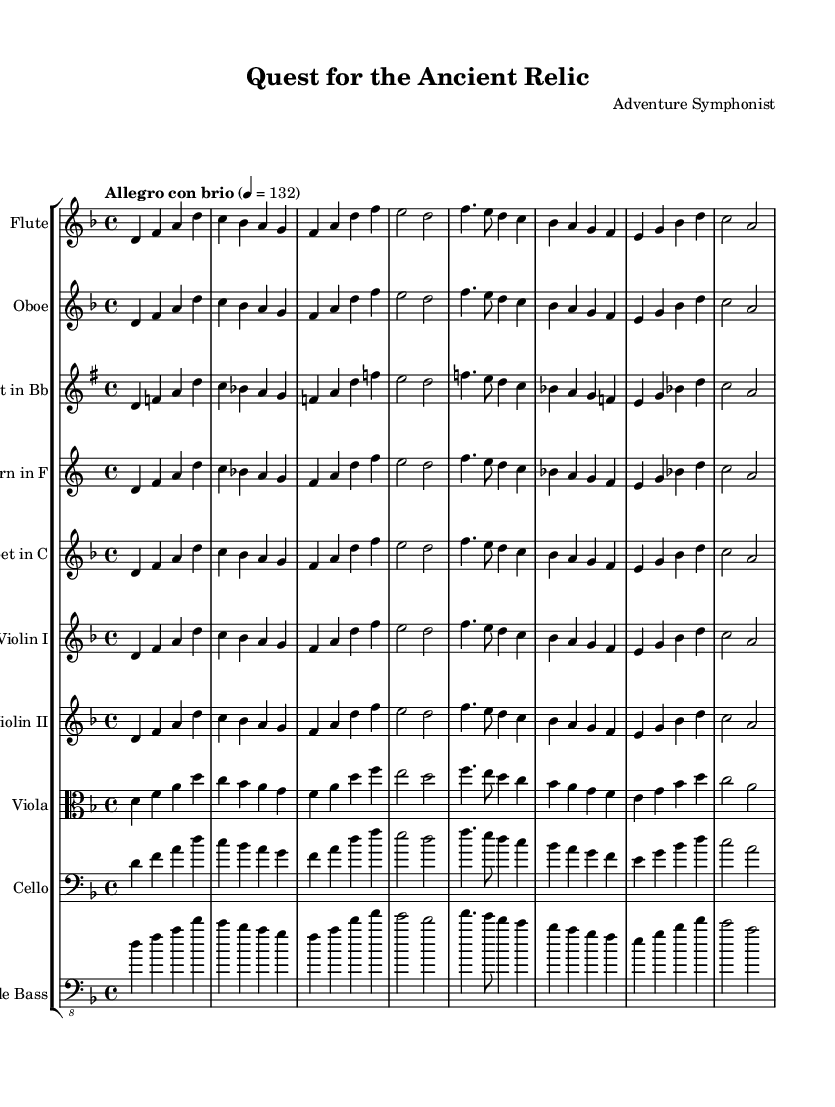What is the key signature of this music? The key signature is indicated at the beginning of the score, which shows one flat (B flat), indicating the piece is in D minor.
Answer: D minor What is the time signature of this music? The time signature is shown at the beginning of the score, represented as a ratio of two numbers, which is 4 over 4, indicating that there are four beats in each measure.
Answer: 4/4 What is the tempo marking of this music? The tempo indication is explicitly written above the staff as "Allegro con brio," which describes the speed and style of the performance.
Answer: Allegro con brio How many different instruments are featured in this score? The score contains ten different staves, each representing a different instrument, allowing us to count all the instruments listed.
Answer: Ten Which instrument plays the main theme first? By examining the order of the staves, we can see that the Flute is the first instrument that presents the main theme.
Answer: Flute What are the pitches of the main theme in musical notation? The main theme is defined by the notes played from the Flute staff, which starts with D, then F, A, D, and continues through the measure, following the specific notes in the relative notation.
Answer: D, F, A, D Which instruments are transposed and to what key are they transposed? The Clarinet in B flat is transposed to C, and the Horn in F is transposed to C. This is indicated in the Staves where both instruments have a "transpose" instruction specifying their new pitch designation.
Answer: Clarinet to C, Horn to C 